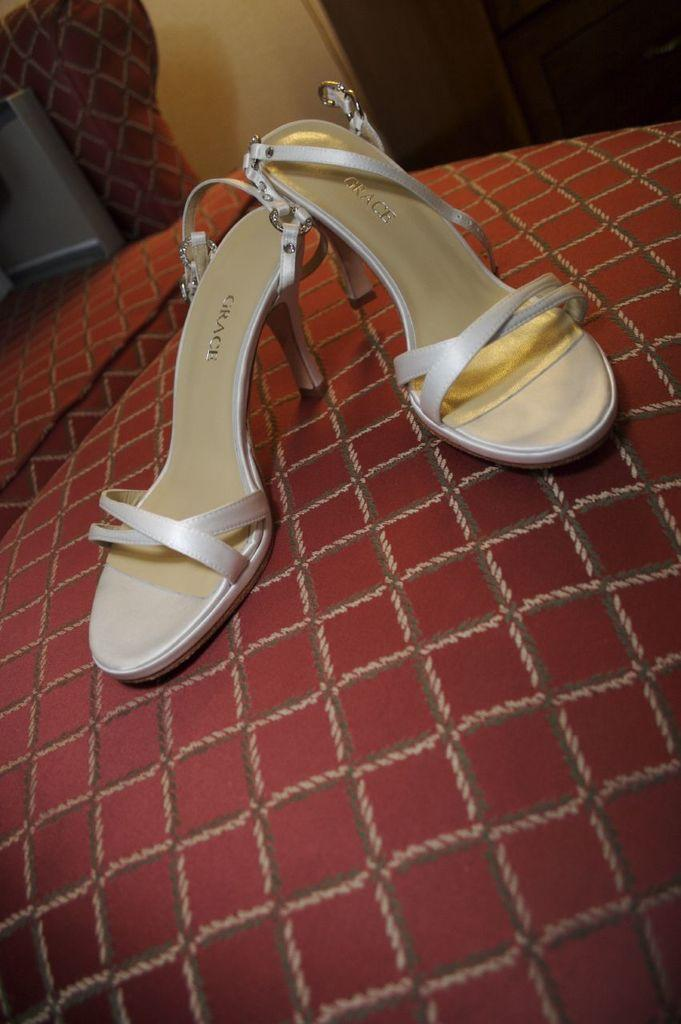What is placed on the red surface in the image? There is footwear on a red surface. What type of furniture can be seen in the image? There is a chair in the image. What is the background of the image composed of? There is a wall in the image. What type of alarm is ringing in the image? There is no alarm present in the image. How does the chair provide comfort in the image? The image does not depict the chair being used, so it cannot be determined how it provides comfort. 